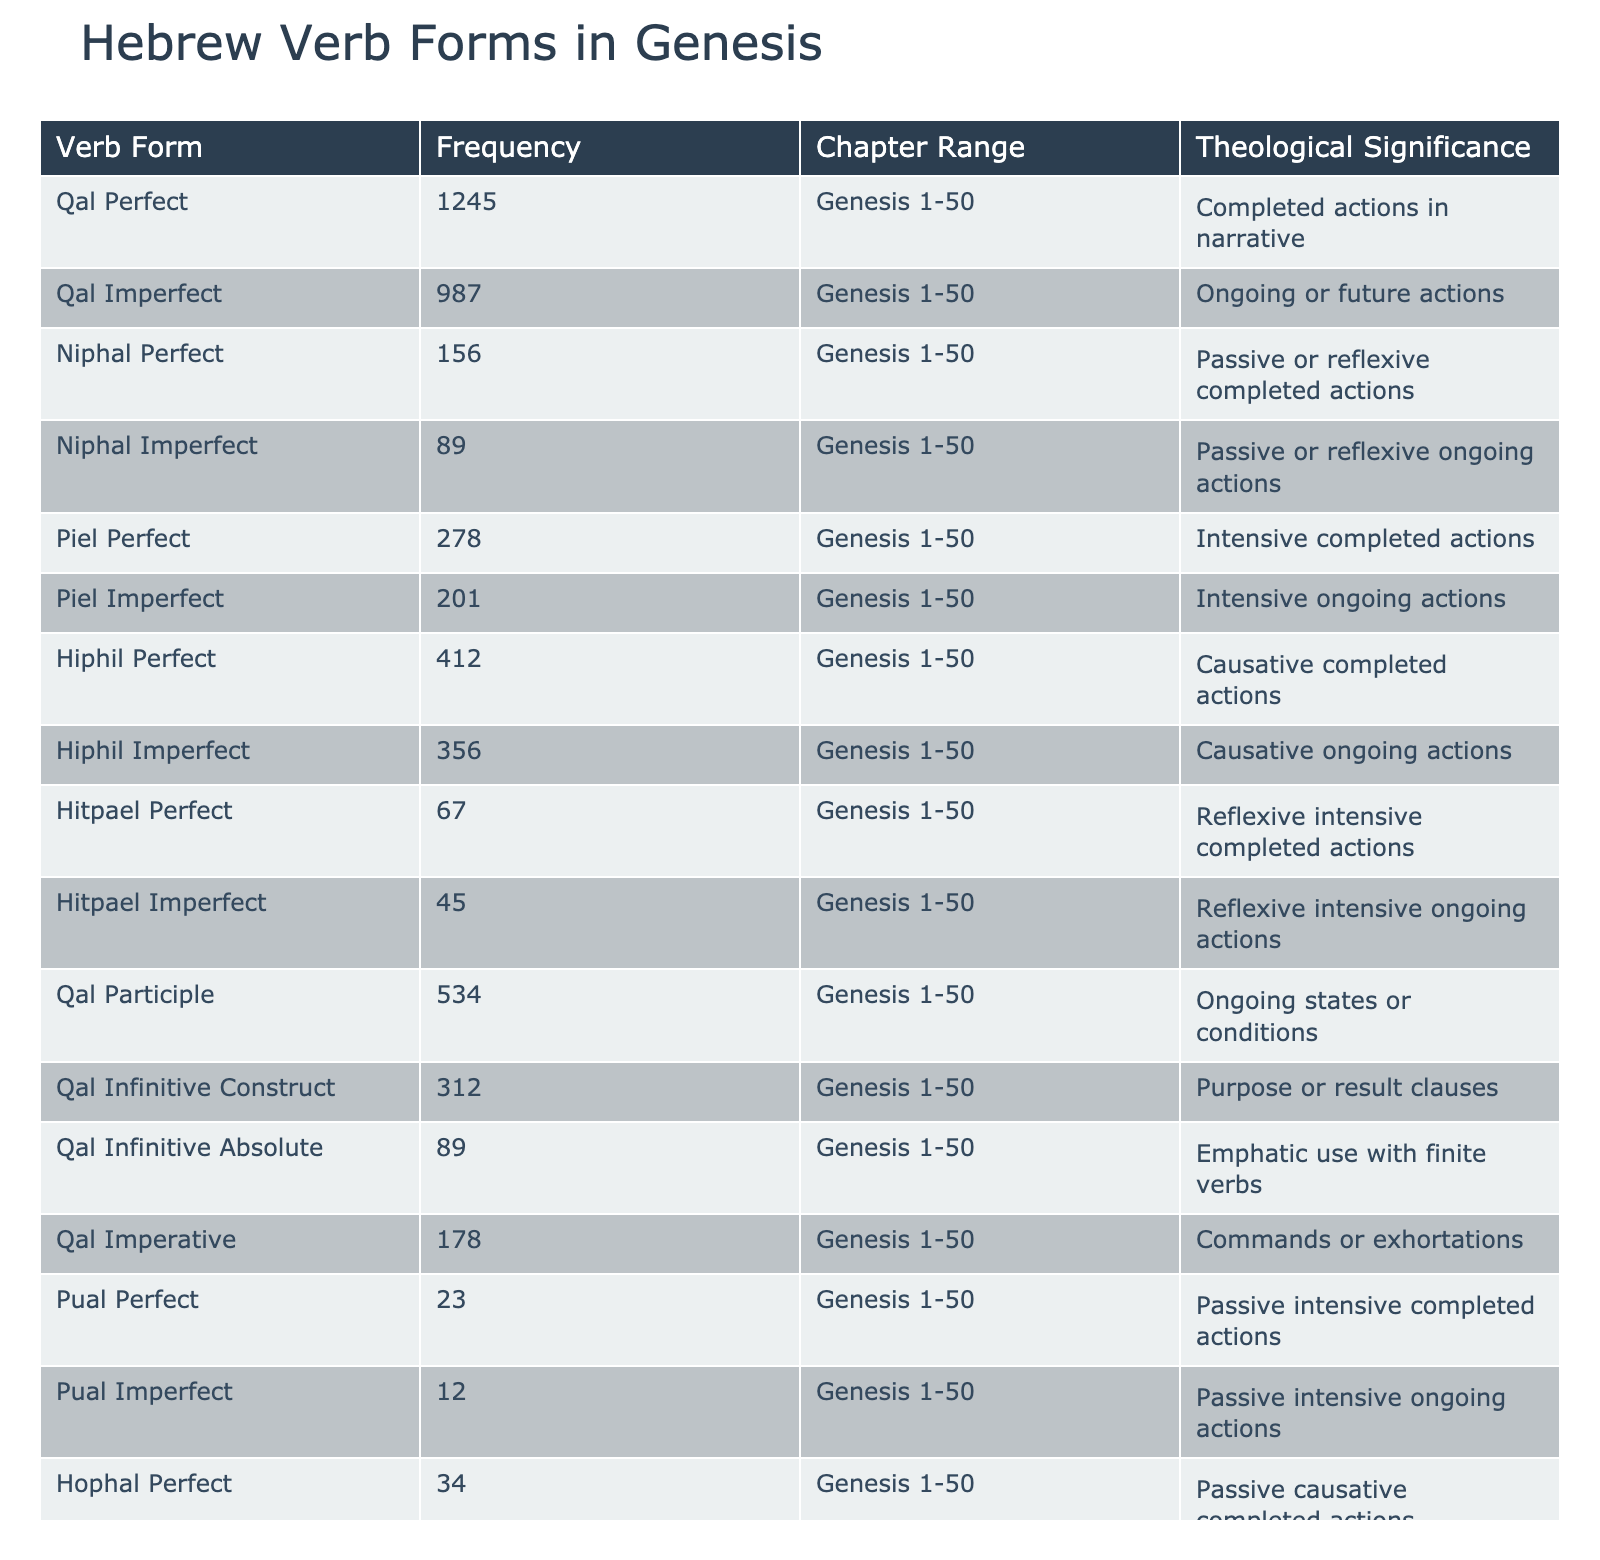What is the most frequent Hebrew verb form in the Book of Genesis? Looking at the table, the "Qal Perfect" has the highest frequency of 1245.
Answer: 1245 How many times does the "Niphal Perfect" verb form appear in Genesis? From the table, the frequency of "Niphal Perfect" is listed as 156.
Answer: 156 What is the frequency of the "Pual Imperfect" verb form? The table shows that the "Pual Imperfect" occurs 12 times in the Book of Genesis.
Answer: 12 Which verb forms have frequencies greater than 300? By examining the table, the following forms exceed 300: "Qal Perfect" (1245), "Qal Imperfect" (987), "Piel Perfect" (278), "Hiphil Perfect" (412), "Qal Participle" (534), and "Qal Infinitive Construct" (312).
Answer: Qal Perfect, Qal Imperfect, Hiphil Perfect, Qal Participle, Qal Infinitive Construct What is the total frequency of all "Imperfect" forms combined? Summing the frequencies of "Qal Imperfect" (987), "Niphal Imperfect" (89), "Piel Imperfect" (201), "Hiphil Imperfect" (356), "Hitpael Imperfect" (45), "Pual Imperfect" (12), and "Hophal Imperfect" (18) gives: 987 + 89 + 201 + 356 + 45 + 12 + 18 = 1708.
Answer: 1708 Is the "Pual Perfect" verb form more frequent than the "Hitpael Perfect"? Comparing the frequencies from the table, "Pual Perfect" (23) is less than "Hitpael Perfect" (67). Therefore, the answer is no.
Answer: No How many total occurrences are there for all "Perfect" verb forms? The Perfect forms are: "Qal Perfect" (1245), "Niphal Perfect" (156), "Piel Perfect" (278), "Hiphil Perfect" (412), "Hitpael Perfect" (67), "Pual Perfect" (23), and "Hophal Perfect" (34). Adding these: 1245 + 156 + 278 + 412 + 67 + 23 + 34 = 2215.
Answer: 2215 Which verb forms have a frequency under 50? Checking the frequencies, "Hitpael Imperfect" (45), "Pual Perfect" (23), "Pual Imperfect" (12), and "Hophal Imperfect" (18) all have a frequency under 50.
Answer: Hitpael Imperfect, Pual Perfect, Pual Imperfect, Hophal Imperfect What is the difference in frequency between the "Hiphil Perfect" and the "Niphal Imperfect"? The frequency of "Hiphil Perfect" is 412 and the "Niphal Imperfect" is 89. The difference is calculated as 412 - 89 = 323.
Answer: 323 Are there more occurrences of "Qal" verb forms than "Niphal" forms combined? The frequencies of "Qal" forms are: "Qal Perfect" (1245), "Qal Imperfect" (987), "Qal Participle" (534), "Qal Infinitive Construct" (312), "Qal Infinitive Absolute" (89), and "Qal Imperative" (178) totaling 3245. The "Niphal" forms are: "Niphal Perfect" (156) and "Niphal Imperfect" (89) totaling 245. Since 3245 > 245, the answer is yes.
Answer: Yes 